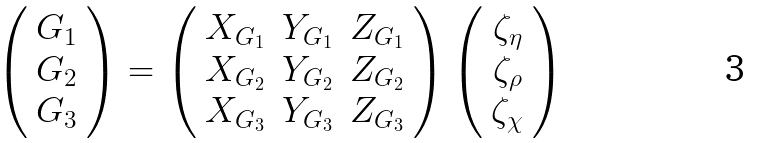<formula> <loc_0><loc_0><loc_500><loc_500>\left ( \begin{array} { c } G _ { 1 } \\ G _ { 2 } \\ G _ { 3 } \\ \end{array} \right ) = \left ( \begin{array} { c c c } X _ { G _ { 1 } } & Y _ { G _ { 1 } } & Z _ { G _ { 1 } } \\ X _ { G _ { 2 } } & Y _ { G _ { 2 } } & Z _ { G _ { 2 } } \\ X _ { G _ { 3 } } & Y _ { G _ { 3 } } & Z _ { G _ { 3 } } \end{array} \right ) \left ( \begin{array} { c } \zeta _ { \eta } \\ \zeta _ { \rho } \\ \zeta _ { \chi } \end{array} \right )</formula> 